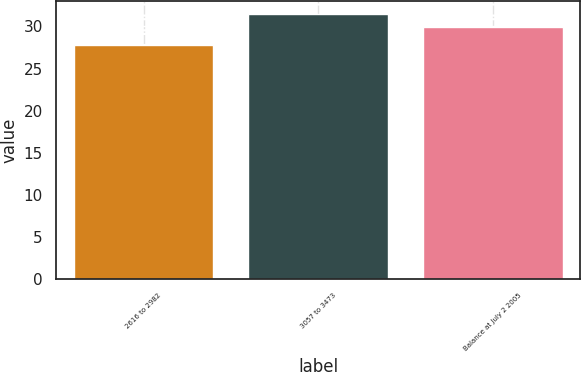<chart> <loc_0><loc_0><loc_500><loc_500><bar_chart><fcel>2616 to 2982<fcel>3057 to 3473<fcel>Balance at July 2 2005<nl><fcel>27.8<fcel>31.45<fcel>29.9<nl></chart> 